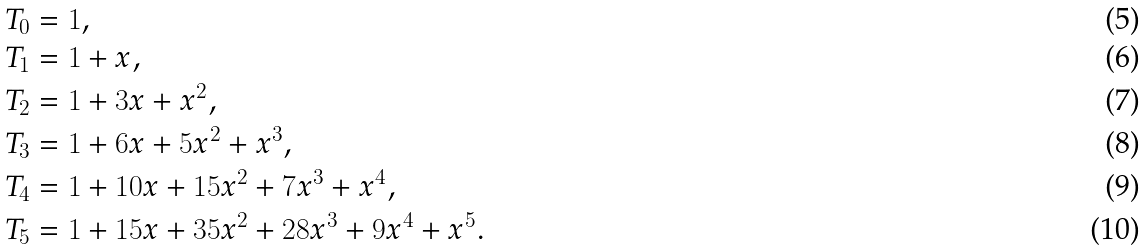Convert formula to latex. <formula><loc_0><loc_0><loc_500><loc_500>T _ { 0 } & = 1 , \\ T _ { 1 } & = 1 + x , \\ T _ { 2 } & = 1 + 3 x + x ^ { 2 } , \\ T _ { 3 } & = 1 + 6 x + 5 x ^ { 2 } + x ^ { 3 } , \\ T _ { 4 } & = 1 + 1 0 x + 1 5 x ^ { 2 } + 7 x ^ { 3 } + x ^ { 4 } , \\ T _ { 5 } & = 1 + 1 5 x + 3 5 x ^ { 2 } + 2 8 x ^ { 3 } + 9 x ^ { 4 } + x ^ { 5 } .</formula> 